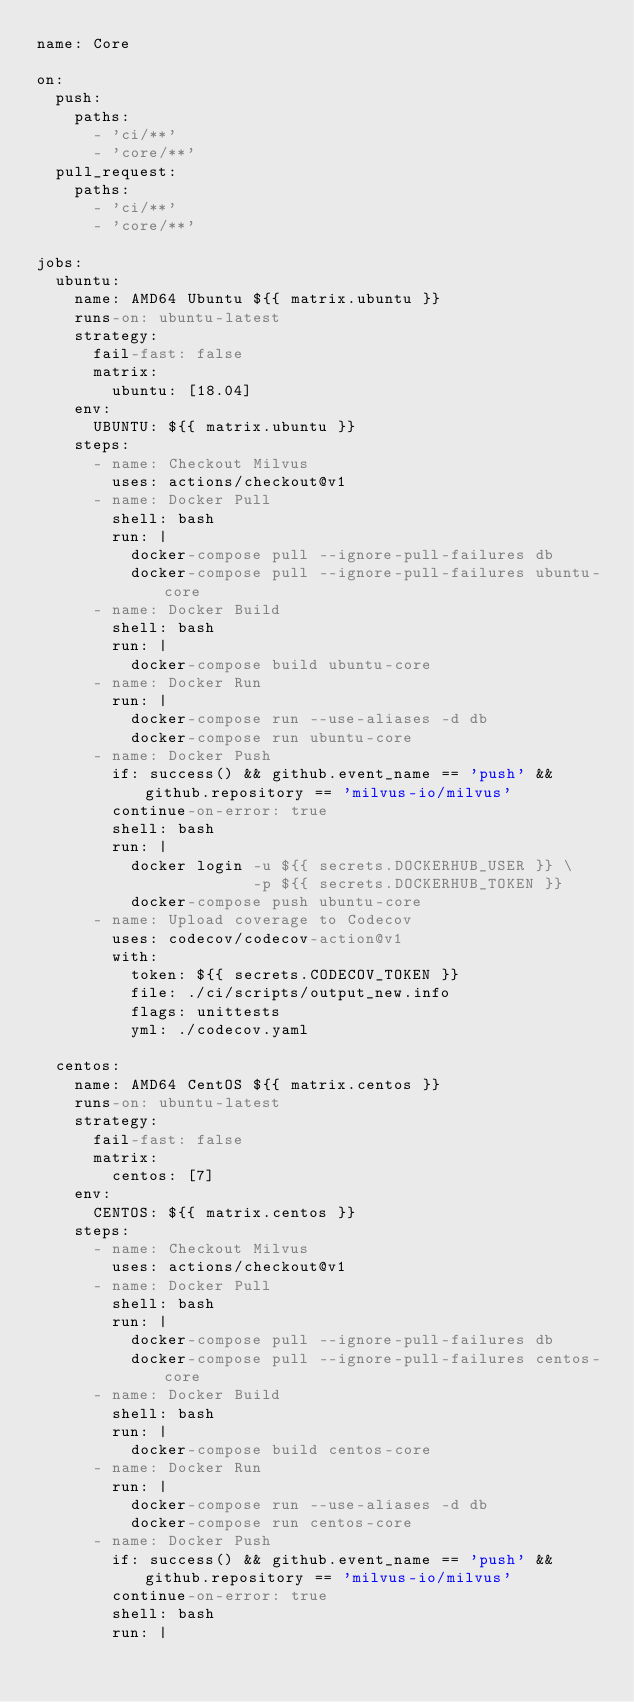<code> <loc_0><loc_0><loc_500><loc_500><_YAML_>name: Core

on:
  push:
    paths:
      - 'ci/**'
      - 'core/**'
  pull_request:
    paths:
      - 'ci/**'
      - 'core/**'

jobs:
  ubuntu:
    name: AMD64 Ubuntu ${{ matrix.ubuntu }}
    runs-on: ubuntu-latest
    strategy:
      fail-fast: false
      matrix:
        ubuntu: [18.04]
    env:
      UBUNTU: ${{ matrix.ubuntu }}
    steps:
      - name: Checkout Milvus
        uses: actions/checkout@v1
      - name: Docker Pull
        shell: bash
        run: |
          docker-compose pull --ignore-pull-failures db
          docker-compose pull --ignore-pull-failures ubuntu-core
      - name: Docker Build
        shell: bash
        run: |
          docker-compose build ubuntu-core
      - name: Docker Run
        run: |
          docker-compose run --use-aliases -d db
          docker-compose run ubuntu-core
      - name: Docker Push
        if: success() && github.event_name == 'push' && github.repository == 'milvus-io/milvus'
        continue-on-error: true
        shell: bash
        run: |
          docker login -u ${{ secrets.DOCKERHUB_USER }} \
                       -p ${{ secrets.DOCKERHUB_TOKEN }}
          docker-compose push ubuntu-core
      - name: Upload coverage to Codecov
        uses: codecov/codecov-action@v1
        with:
          token: ${{ secrets.CODECOV_TOKEN }}
          file: ./ci/scripts/output_new.info
          flags: unittests
          yml: ./codecov.yaml

  centos:
    name: AMD64 CentOS ${{ matrix.centos }}
    runs-on: ubuntu-latest
    strategy:
      fail-fast: false
      matrix:
        centos: [7]
    env:
      CENTOS: ${{ matrix.centos }}
    steps:
      - name: Checkout Milvus
        uses: actions/checkout@v1
      - name: Docker Pull
        shell: bash
        run: |
          docker-compose pull --ignore-pull-failures db
          docker-compose pull --ignore-pull-failures centos-core
      - name: Docker Build
        shell: bash
        run: |
          docker-compose build centos-core
      - name: Docker Run
        run: |
          docker-compose run --use-aliases -d db
          docker-compose run centos-core
      - name: Docker Push
        if: success() && github.event_name == 'push' && github.repository == 'milvus-io/milvus'
        continue-on-error: true
        shell: bash
        run: |</code> 